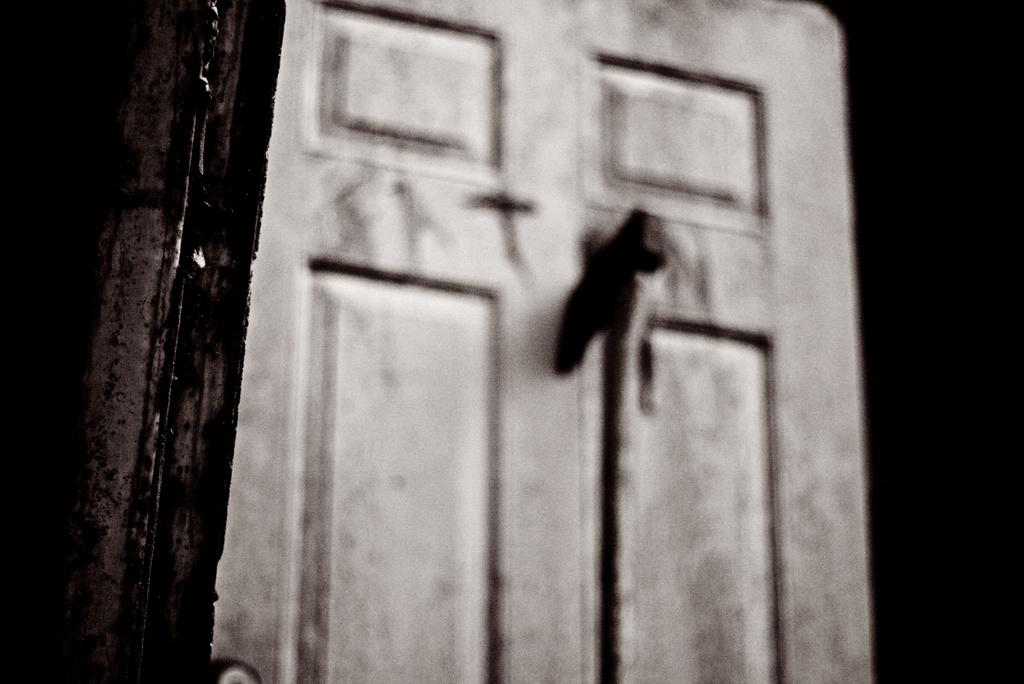What is the main object in the image? There is a door in the image. Can you describe the background of the image? The background of the image is dark. How many ears can be seen on the door in the image? There are no ears present on the door in the image. Is the person's aunt visible in the image? There is no person or aunt present in the image; it only features a door. Are there any lizards crawling on the door in the image? There are no lizards present on the door in the image. 